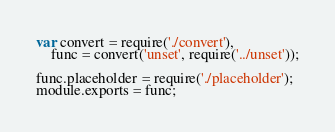<code> <loc_0><loc_0><loc_500><loc_500><_JavaScript_>var convert = require('./convert'),
    func = convert('unset', require('../unset'));

func.placeholder = require('./placeholder');
module.exports = func;</code> 